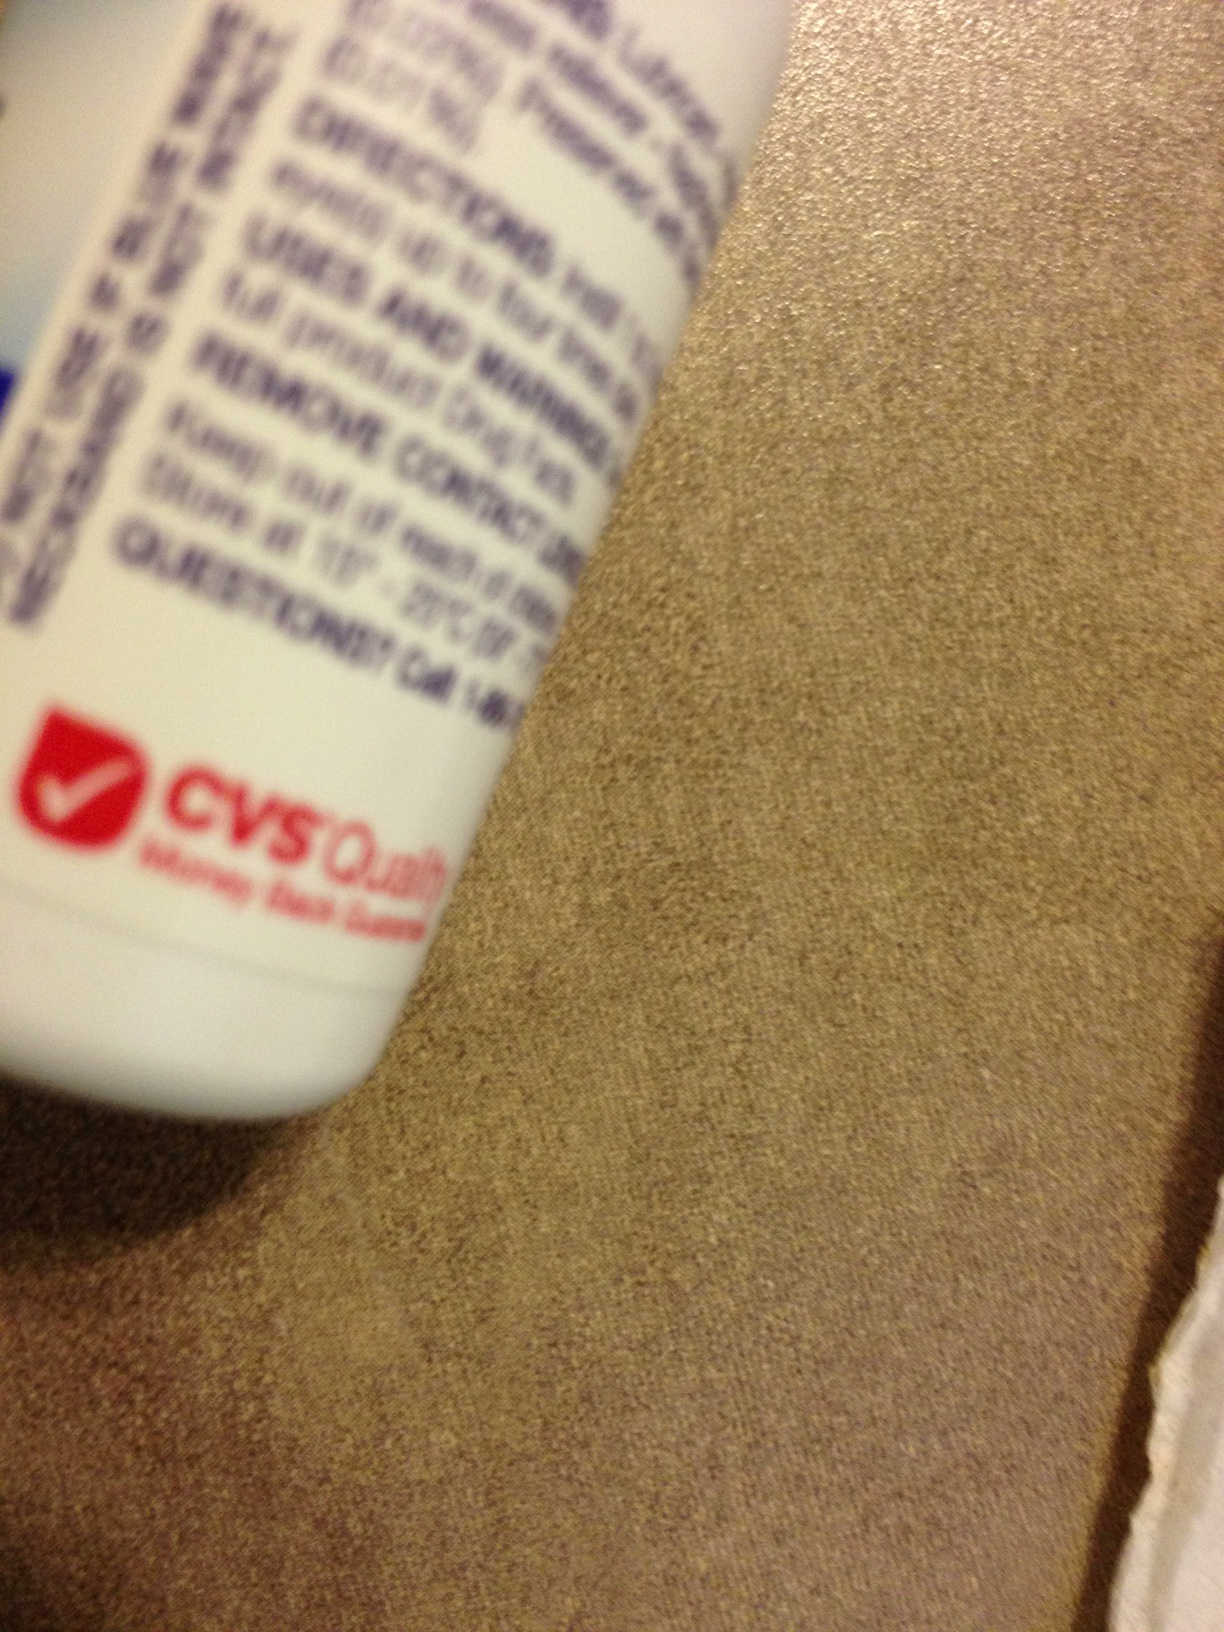Is it possible to know the ingredients from this image? From this particular angle, the list of ingredients is obscured and cannot be read. To know the ingredients, one would need a clearer view of the label where such information is typically listed. 